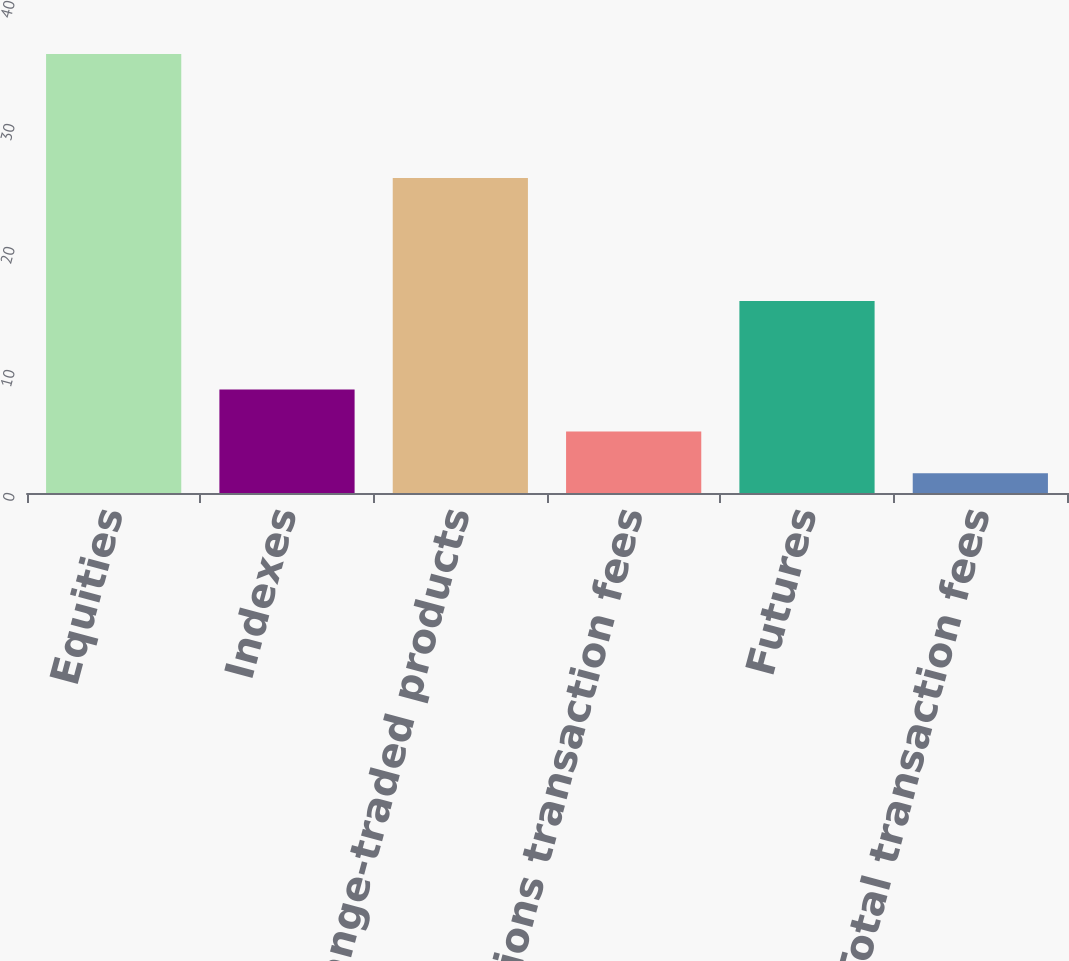Convert chart. <chart><loc_0><loc_0><loc_500><loc_500><bar_chart><fcel>Equities<fcel>Indexes<fcel>Exchange-traded products<fcel>Total options transaction fees<fcel>Futures<fcel>Total transaction fees<nl><fcel>35.7<fcel>8.42<fcel>25.6<fcel>5.01<fcel>15.6<fcel>1.6<nl></chart> 